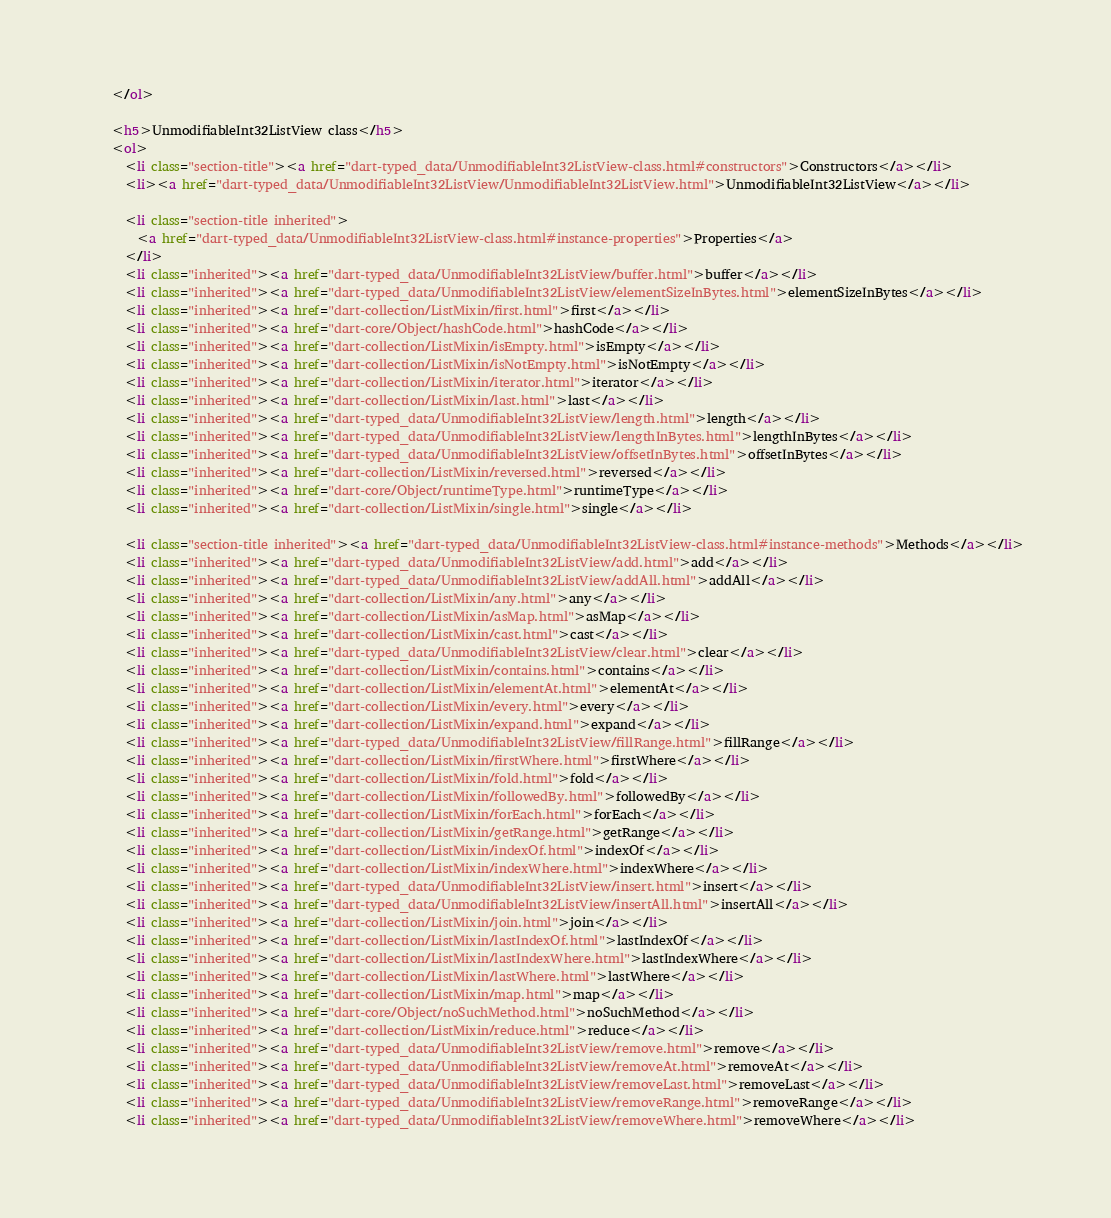<code> <loc_0><loc_0><loc_500><loc_500><_HTML_>    </ol>
    
    <h5>UnmodifiableInt32ListView class</h5>
    <ol>
      <li class="section-title"><a href="dart-typed_data/UnmodifiableInt32ListView-class.html#constructors">Constructors</a></li>
      <li><a href="dart-typed_data/UnmodifiableInt32ListView/UnmodifiableInt32ListView.html">UnmodifiableInt32ListView</a></li>
    
      <li class="section-title inherited">
        <a href="dart-typed_data/UnmodifiableInt32ListView-class.html#instance-properties">Properties</a>
      </li>
      <li class="inherited"><a href="dart-typed_data/UnmodifiableInt32ListView/buffer.html">buffer</a></li>
      <li class="inherited"><a href="dart-typed_data/UnmodifiableInt32ListView/elementSizeInBytes.html">elementSizeInBytes</a></li>
      <li class="inherited"><a href="dart-collection/ListMixin/first.html">first</a></li>
      <li class="inherited"><a href="dart-core/Object/hashCode.html">hashCode</a></li>
      <li class="inherited"><a href="dart-collection/ListMixin/isEmpty.html">isEmpty</a></li>
      <li class="inherited"><a href="dart-collection/ListMixin/isNotEmpty.html">isNotEmpty</a></li>
      <li class="inherited"><a href="dart-collection/ListMixin/iterator.html">iterator</a></li>
      <li class="inherited"><a href="dart-collection/ListMixin/last.html">last</a></li>
      <li class="inherited"><a href="dart-typed_data/UnmodifiableInt32ListView/length.html">length</a></li>
      <li class="inherited"><a href="dart-typed_data/UnmodifiableInt32ListView/lengthInBytes.html">lengthInBytes</a></li>
      <li class="inherited"><a href="dart-typed_data/UnmodifiableInt32ListView/offsetInBytes.html">offsetInBytes</a></li>
      <li class="inherited"><a href="dart-collection/ListMixin/reversed.html">reversed</a></li>
      <li class="inherited"><a href="dart-core/Object/runtimeType.html">runtimeType</a></li>
      <li class="inherited"><a href="dart-collection/ListMixin/single.html">single</a></li>
    
      <li class="section-title inherited"><a href="dart-typed_data/UnmodifiableInt32ListView-class.html#instance-methods">Methods</a></li>
      <li class="inherited"><a href="dart-typed_data/UnmodifiableInt32ListView/add.html">add</a></li>
      <li class="inherited"><a href="dart-typed_data/UnmodifiableInt32ListView/addAll.html">addAll</a></li>
      <li class="inherited"><a href="dart-collection/ListMixin/any.html">any</a></li>
      <li class="inherited"><a href="dart-collection/ListMixin/asMap.html">asMap</a></li>
      <li class="inherited"><a href="dart-collection/ListMixin/cast.html">cast</a></li>
      <li class="inherited"><a href="dart-typed_data/UnmodifiableInt32ListView/clear.html">clear</a></li>
      <li class="inherited"><a href="dart-collection/ListMixin/contains.html">contains</a></li>
      <li class="inherited"><a href="dart-collection/ListMixin/elementAt.html">elementAt</a></li>
      <li class="inherited"><a href="dart-collection/ListMixin/every.html">every</a></li>
      <li class="inherited"><a href="dart-collection/ListMixin/expand.html">expand</a></li>
      <li class="inherited"><a href="dart-typed_data/UnmodifiableInt32ListView/fillRange.html">fillRange</a></li>
      <li class="inherited"><a href="dart-collection/ListMixin/firstWhere.html">firstWhere</a></li>
      <li class="inherited"><a href="dart-collection/ListMixin/fold.html">fold</a></li>
      <li class="inherited"><a href="dart-collection/ListMixin/followedBy.html">followedBy</a></li>
      <li class="inherited"><a href="dart-collection/ListMixin/forEach.html">forEach</a></li>
      <li class="inherited"><a href="dart-collection/ListMixin/getRange.html">getRange</a></li>
      <li class="inherited"><a href="dart-collection/ListMixin/indexOf.html">indexOf</a></li>
      <li class="inherited"><a href="dart-collection/ListMixin/indexWhere.html">indexWhere</a></li>
      <li class="inherited"><a href="dart-typed_data/UnmodifiableInt32ListView/insert.html">insert</a></li>
      <li class="inherited"><a href="dart-typed_data/UnmodifiableInt32ListView/insertAll.html">insertAll</a></li>
      <li class="inherited"><a href="dart-collection/ListMixin/join.html">join</a></li>
      <li class="inherited"><a href="dart-collection/ListMixin/lastIndexOf.html">lastIndexOf</a></li>
      <li class="inherited"><a href="dart-collection/ListMixin/lastIndexWhere.html">lastIndexWhere</a></li>
      <li class="inherited"><a href="dart-collection/ListMixin/lastWhere.html">lastWhere</a></li>
      <li class="inherited"><a href="dart-collection/ListMixin/map.html">map</a></li>
      <li class="inherited"><a href="dart-core/Object/noSuchMethod.html">noSuchMethod</a></li>
      <li class="inherited"><a href="dart-collection/ListMixin/reduce.html">reduce</a></li>
      <li class="inherited"><a href="dart-typed_data/UnmodifiableInt32ListView/remove.html">remove</a></li>
      <li class="inherited"><a href="dart-typed_data/UnmodifiableInt32ListView/removeAt.html">removeAt</a></li>
      <li class="inherited"><a href="dart-typed_data/UnmodifiableInt32ListView/removeLast.html">removeLast</a></li>
      <li class="inherited"><a href="dart-typed_data/UnmodifiableInt32ListView/removeRange.html">removeRange</a></li>
      <li class="inherited"><a href="dart-typed_data/UnmodifiableInt32ListView/removeWhere.html">removeWhere</a></li></code> 